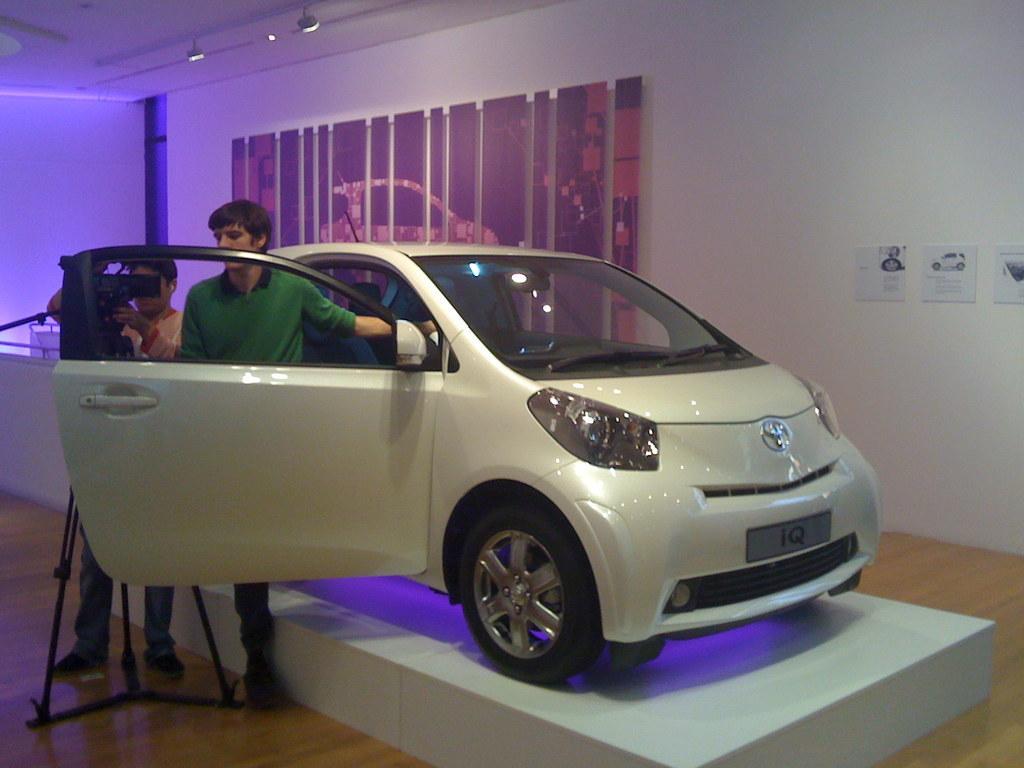How would you summarize this image in a sentence or two? There are two men standing and we can see camera with stand,behind these men we can see car on the surface. Background we can see posts on a wall and lights. 